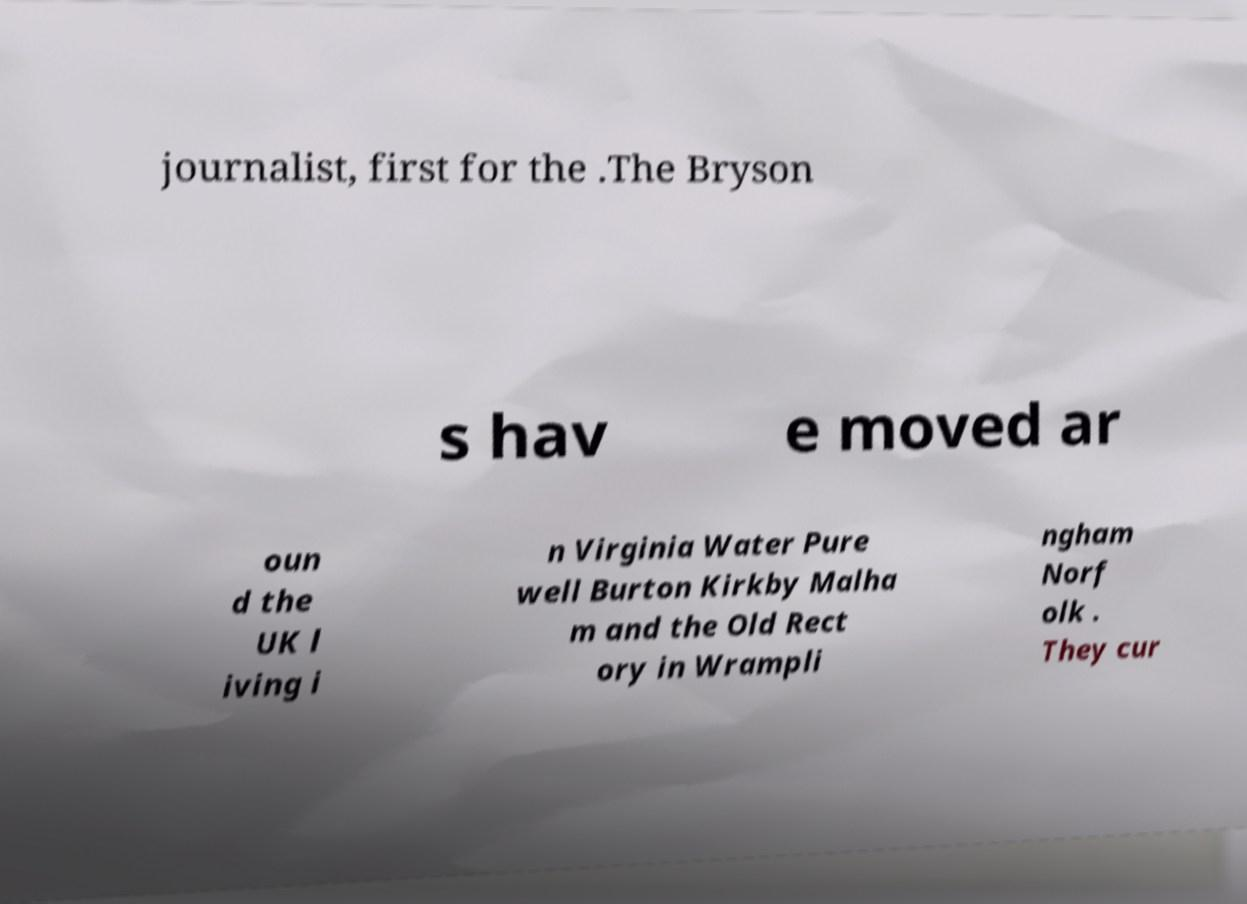Please identify and transcribe the text found in this image. journalist, first for the .The Bryson s hav e moved ar oun d the UK l iving i n Virginia Water Pure well Burton Kirkby Malha m and the Old Rect ory in Wrampli ngham Norf olk . They cur 